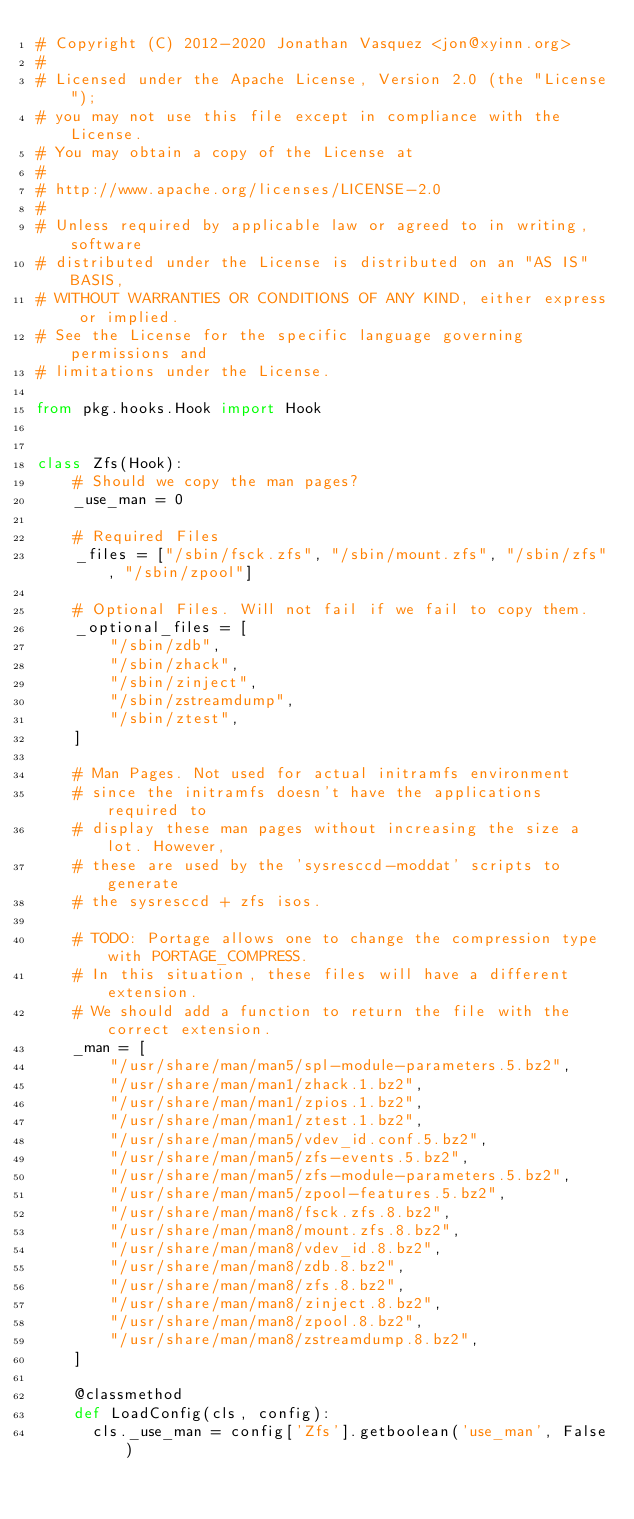<code> <loc_0><loc_0><loc_500><loc_500><_Python_># Copyright (C) 2012-2020 Jonathan Vasquez <jon@xyinn.org>
#
# Licensed under the Apache License, Version 2.0 (the "License");
# you may not use this file except in compliance with the License.
# You may obtain a copy of the License at
#
# http://www.apache.org/licenses/LICENSE-2.0
#
# Unless required by applicable law or agreed to in writing, software
# distributed under the License is distributed on an "AS IS" BASIS,
# WITHOUT WARRANTIES OR CONDITIONS OF ANY KIND, either express or implied.
# See the License for the specific language governing permissions and
# limitations under the License.

from pkg.hooks.Hook import Hook


class Zfs(Hook):
    # Should we copy the man pages?
    _use_man = 0

    # Required Files
    _files = ["/sbin/fsck.zfs", "/sbin/mount.zfs", "/sbin/zfs", "/sbin/zpool"]

    # Optional Files. Will not fail if we fail to copy them.
    _optional_files = [
        "/sbin/zdb",
        "/sbin/zhack",
        "/sbin/zinject",
        "/sbin/zstreamdump",
        "/sbin/ztest",
    ]

    # Man Pages. Not used for actual initramfs environment
    # since the initramfs doesn't have the applications required to
    # display these man pages without increasing the size a lot. However,
    # these are used by the 'sysresccd-moddat' scripts to generate
    # the sysresccd + zfs isos.

    # TODO: Portage allows one to change the compression type with PORTAGE_COMPRESS.
    # In this situation, these files will have a different extension.
    # We should add a function to return the file with the correct extension.
    _man = [
        "/usr/share/man/man5/spl-module-parameters.5.bz2",
        "/usr/share/man/man1/zhack.1.bz2",
        "/usr/share/man/man1/zpios.1.bz2",
        "/usr/share/man/man1/ztest.1.bz2",
        "/usr/share/man/man5/vdev_id.conf.5.bz2",
        "/usr/share/man/man5/zfs-events.5.bz2",
        "/usr/share/man/man5/zfs-module-parameters.5.bz2",
        "/usr/share/man/man5/zpool-features.5.bz2",
        "/usr/share/man/man8/fsck.zfs.8.bz2",
        "/usr/share/man/man8/mount.zfs.8.bz2",
        "/usr/share/man/man8/vdev_id.8.bz2",
        "/usr/share/man/man8/zdb.8.bz2",
        "/usr/share/man/man8/zfs.8.bz2",
        "/usr/share/man/man8/zinject.8.bz2",
        "/usr/share/man/man8/zpool.8.bz2",
        "/usr/share/man/man8/zstreamdump.8.bz2",
    ]

    @classmethod
    def LoadConfig(cls, config):
      cls._use_man = config['Zfs'].getboolean('use_man', False)
</code> 